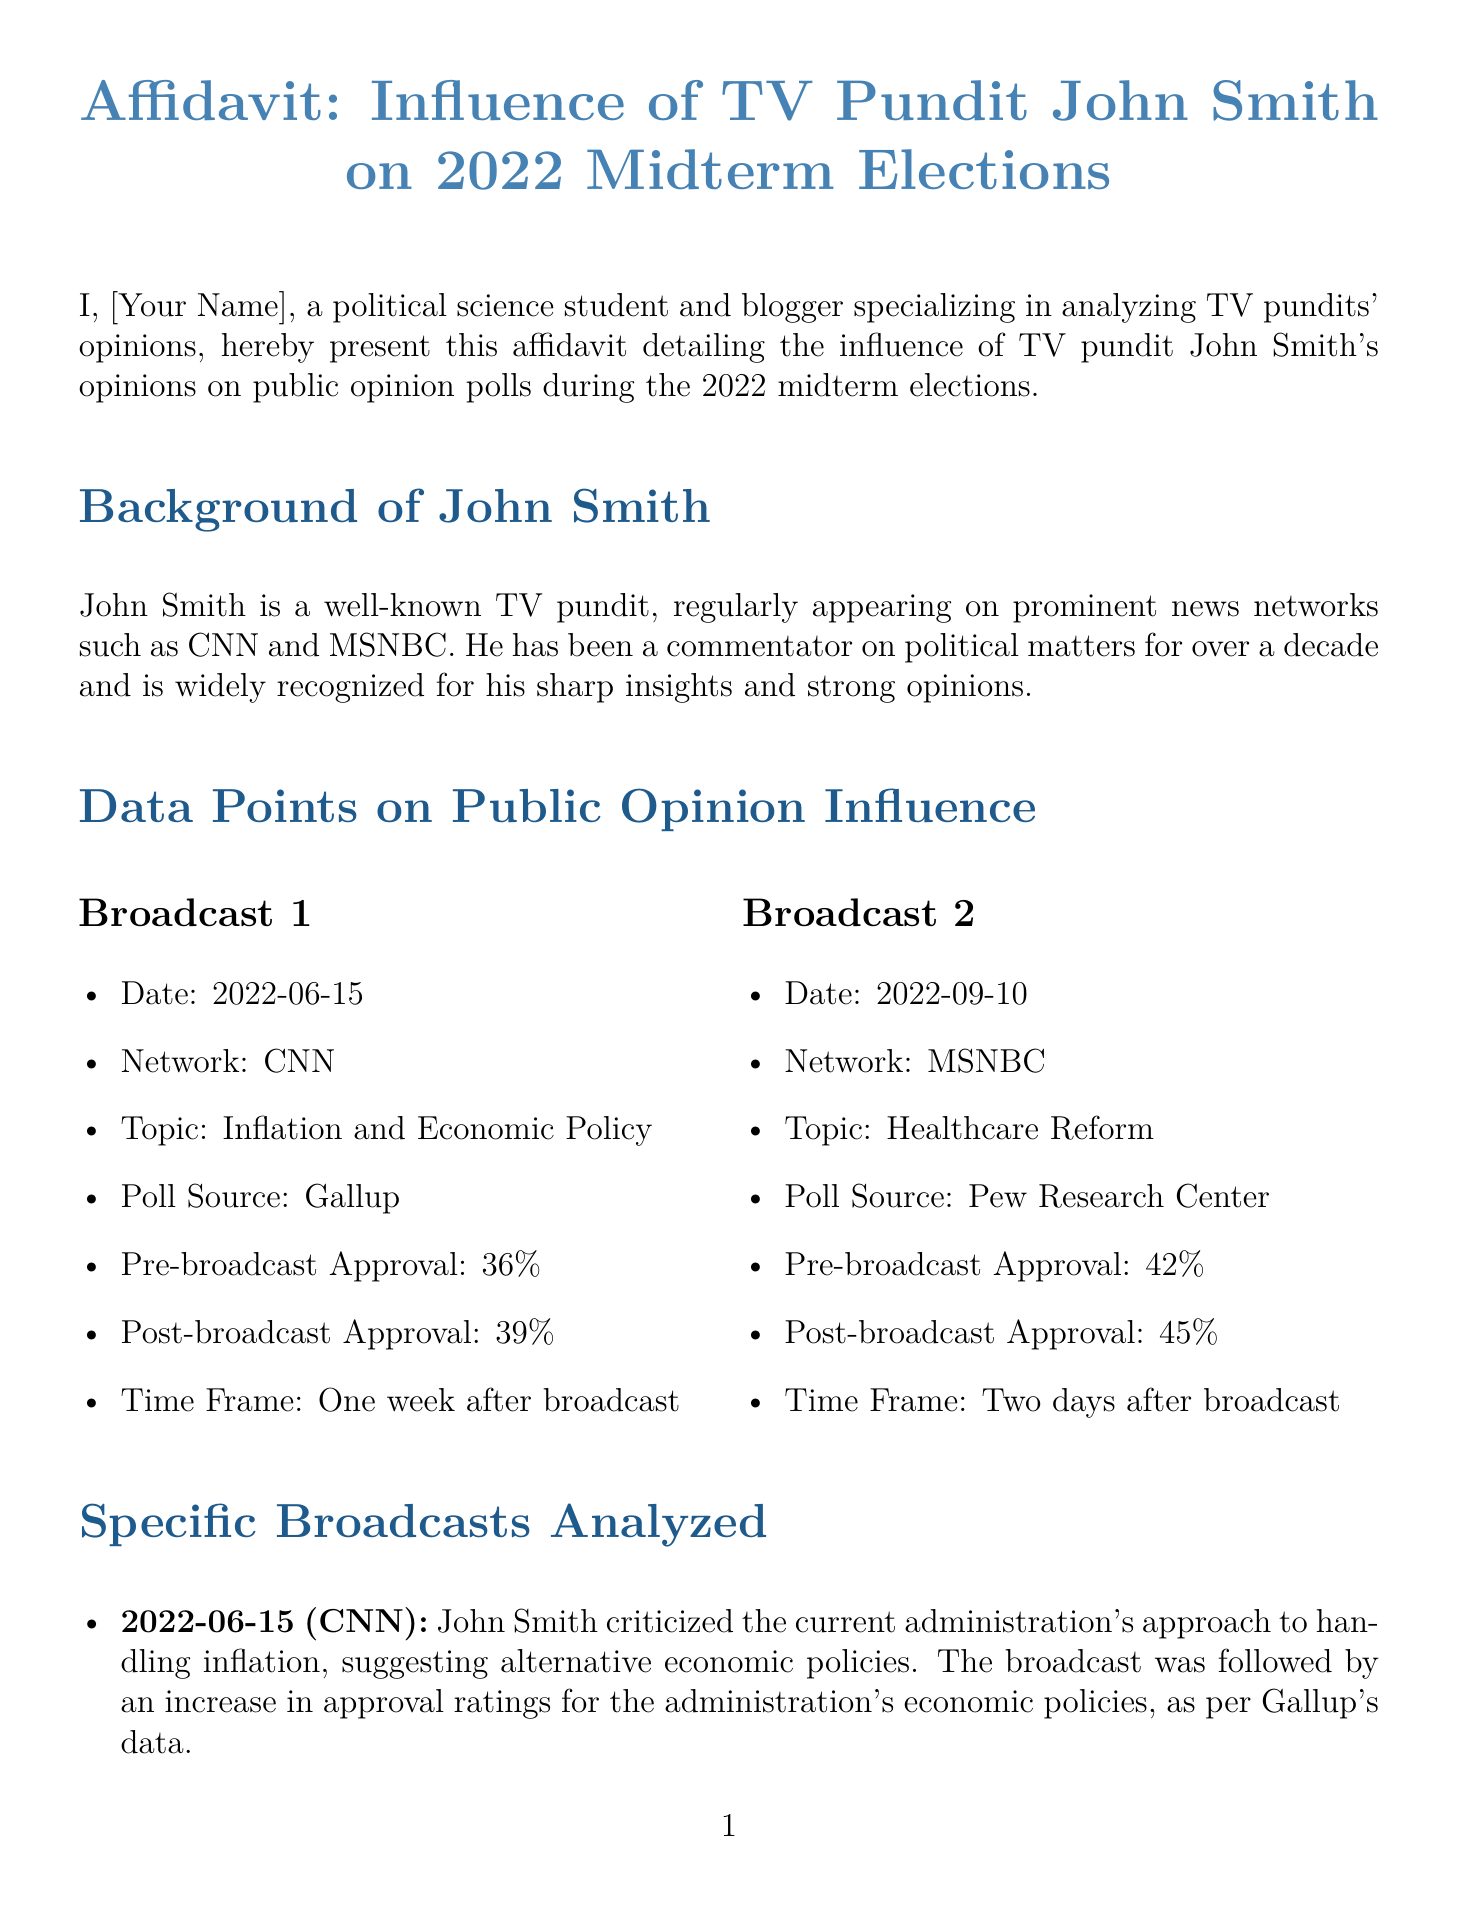What is the name of the TV pundit analyzed? The document presents an affidavit about John Smith, a well-known TV pundit.
Answer: John Smith What is the date of the first broadcast analyzed? The first broadcast analyzed in the affidavit was on June 15, 2022.
Answer: 2022-06-15 What network aired the second broadcast? The second broadcast mentioned was aired on MSNBC.
Answer: MSNBC What was the pre-broadcast approval rating for the topic of Inflation? According to the document, the pre-broadcast approval rating for Inflation was 36%.
Answer: 36% How much did the approval rating increase after the first broadcast? The approval rating increased from 36% to 39% after the first broadcast.
Answer: 3% What topic did John Smith advocate for in the second broadcast? The second broadcast focused on Healthcare Reform.
Answer: Healthcare Reform What was the source of the poll data for the Healthcare Reform broadcast? The source of the poll data for the Healthcare Reform broadcast was Pew Research Center.
Answer: Pew Research Center What type of document is this affidavit classified as? The document is classified as an affidavit, which is a formal sworn statement.
Answer: Affidavit How long after the second broadcast was the public opinion measure taken? The public opinion measure for the second broadcast was taken two days after the broadcast.
Answer: Two days 